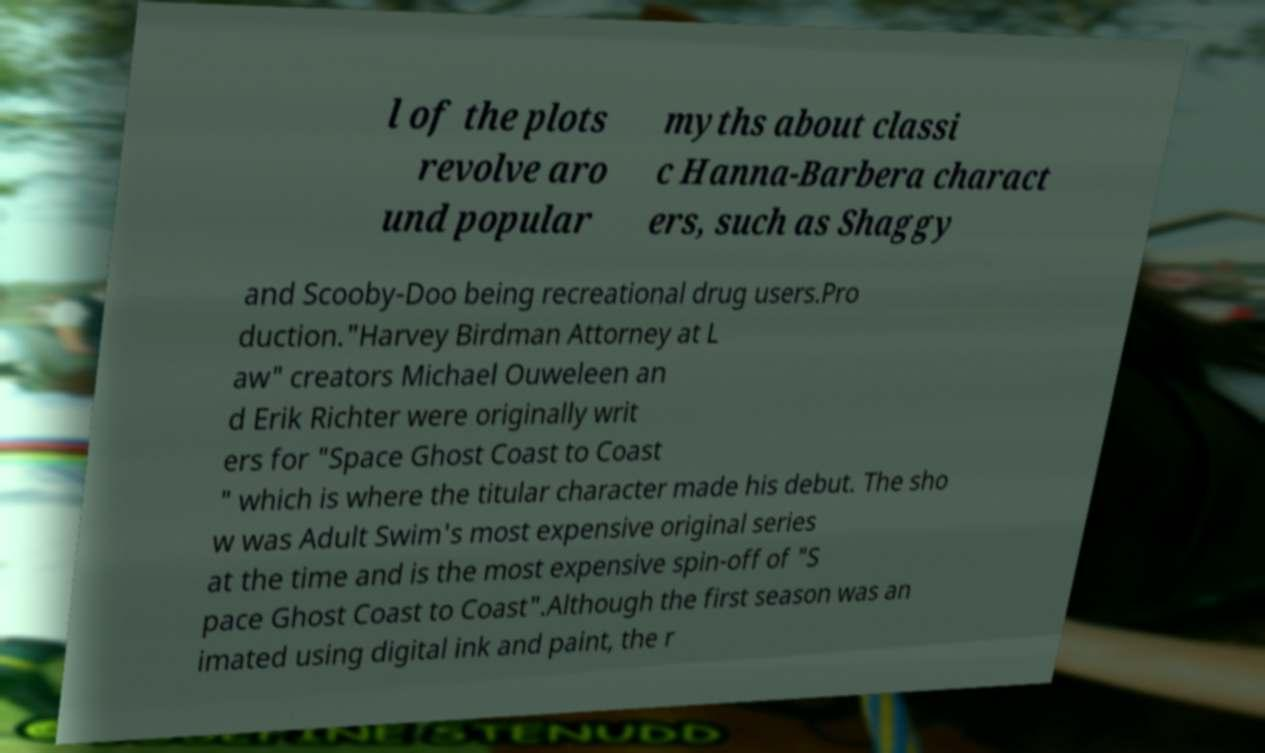Can you accurately transcribe the text from the provided image for me? l of the plots revolve aro und popular myths about classi c Hanna-Barbera charact ers, such as Shaggy and Scooby-Doo being recreational drug users.Pro duction."Harvey Birdman Attorney at L aw" creators Michael Ouweleen an d Erik Richter were originally writ ers for "Space Ghost Coast to Coast " which is where the titular character made his debut. The sho w was Adult Swim's most expensive original series at the time and is the most expensive spin-off of "S pace Ghost Coast to Coast".Although the first season was an imated using digital ink and paint, the r 